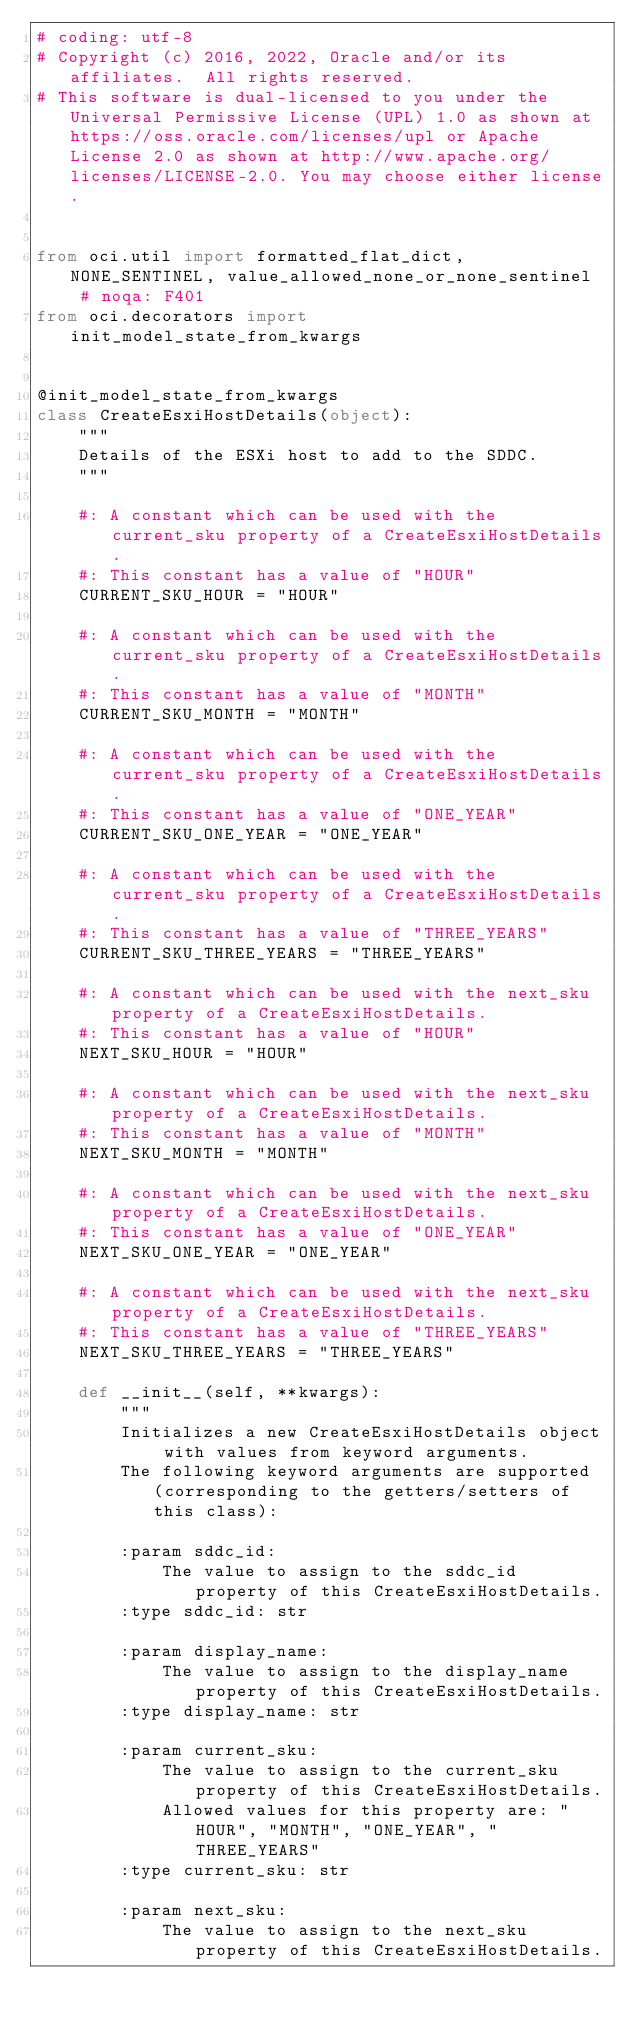<code> <loc_0><loc_0><loc_500><loc_500><_Python_># coding: utf-8
# Copyright (c) 2016, 2022, Oracle and/or its affiliates.  All rights reserved.
# This software is dual-licensed to you under the Universal Permissive License (UPL) 1.0 as shown at https://oss.oracle.com/licenses/upl or Apache License 2.0 as shown at http://www.apache.org/licenses/LICENSE-2.0. You may choose either license.


from oci.util import formatted_flat_dict, NONE_SENTINEL, value_allowed_none_or_none_sentinel  # noqa: F401
from oci.decorators import init_model_state_from_kwargs


@init_model_state_from_kwargs
class CreateEsxiHostDetails(object):
    """
    Details of the ESXi host to add to the SDDC.
    """

    #: A constant which can be used with the current_sku property of a CreateEsxiHostDetails.
    #: This constant has a value of "HOUR"
    CURRENT_SKU_HOUR = "HOUR"

    #: A constant which can be used with the current_sku property of a CreateEsxiHostDetails.
    #: This constant has a value of "MONTH"
    CURRENT_SKU_MONTH = "MONTH"

    #: A constant which can be used with the current_sku property of a CreateEsxiHostDetails.
    #: This constant has a value of "ONE_YEAR"
    CURRENT_SKU_ONE_YEAR = "ONE_YEAR"

    #: A constant which can be used with the current_sku property of a CreateEsxiHostDetails.
    #: This constant has a value of "THREE_YEARS"
    CURRENT_SKU_THREE_YEARS = "THREE_YEARS"

    #: A constant which can be used with the next_sku property of a CreateEsxiHostDetails.
    #: This constant has a value of "HOUR"
    NEXT_SKU_HOUR = "HOUR"

    #: A constant which can be used with the next_sku property of a CreateEsxiHostDetails.
    #: This constant has a value of "MONTH"
    NEXT_SKU_MONTH = "MONTH"

    #: A constant which can be used with the next_sku property of a CreateEsxiHostDetails.
    #: This constant has a value of "ONE_YEAR"
    NEXT_SKU_ONE_YEAR = "ONE_YEAR"

    #: A constant which can be used with the next_sku property of a CreateEsxiHostDetails.
    #: This constant has a value of "THREE_YEARS"
    NEXT_SKU_THREE_YEARS = "THREE_YEARS"

    def __init__(self, **kwargs):
        """
        Initializes a new CreateEsxiHostDetails object with values from keyword arguments.
        The following keyword arguments are supported (corresponding to the getters/setters of this class):

        :param sddc_id:
            The value to assign to the sddc_id property of this CreateEsxiHostDetails.
        :type sddc_id: str

        :param display_name:
            The value to assign to the display_name property of this CreateEsxiHostDetails.
        :type display_name: str

        :param current_sku:
            The value to assign to the current_sku property of this CreateEsxiHostDetails.
            Allowed values for this property are: "HOUR", "MONTH", "ONE_YEAR", "THREE_YEARS"
        :type current_sku: str

        :param next_sku:
            The value to assign to the next_sku property of this CreateEsxiHostDetails.</code> 